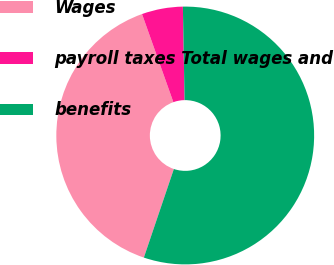<chart> <loc_0><loc_0><loc_500><loc_500><pie_chart><fcel>Wages<fcel>payroll taxes Total wages and<fcel>benefits<nl><fcel>39.36%<fcel>5.15%<fcel>55.49%<nl></chart> 